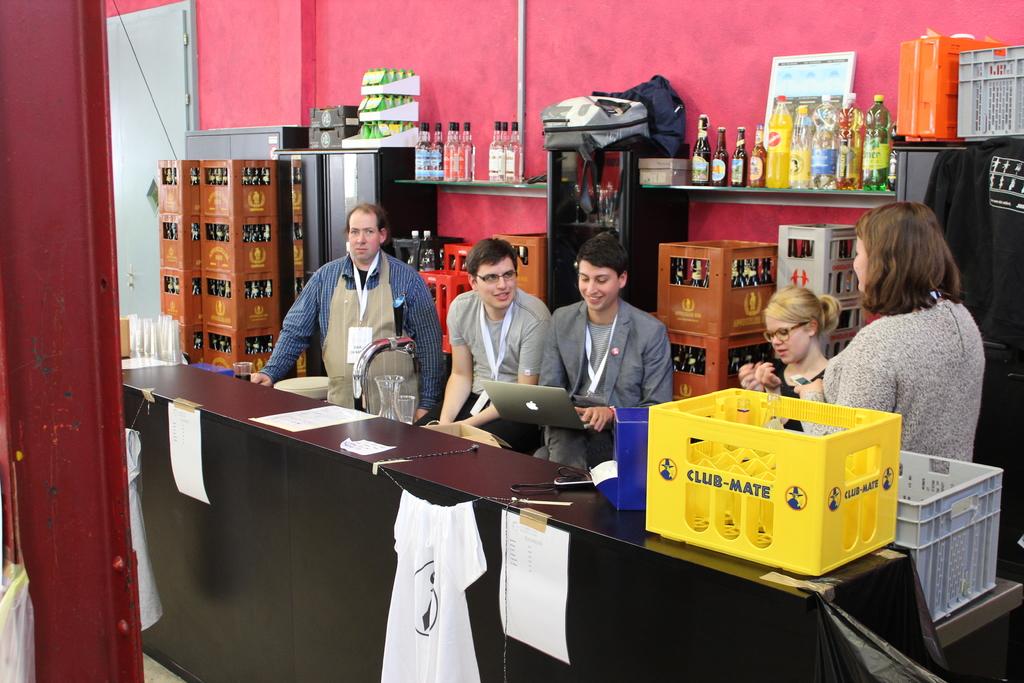What's the brand name on the yellow basket?
Make the answer very short. Club-mate. What brand is the laptop?
Your response must be concise. Apple. 